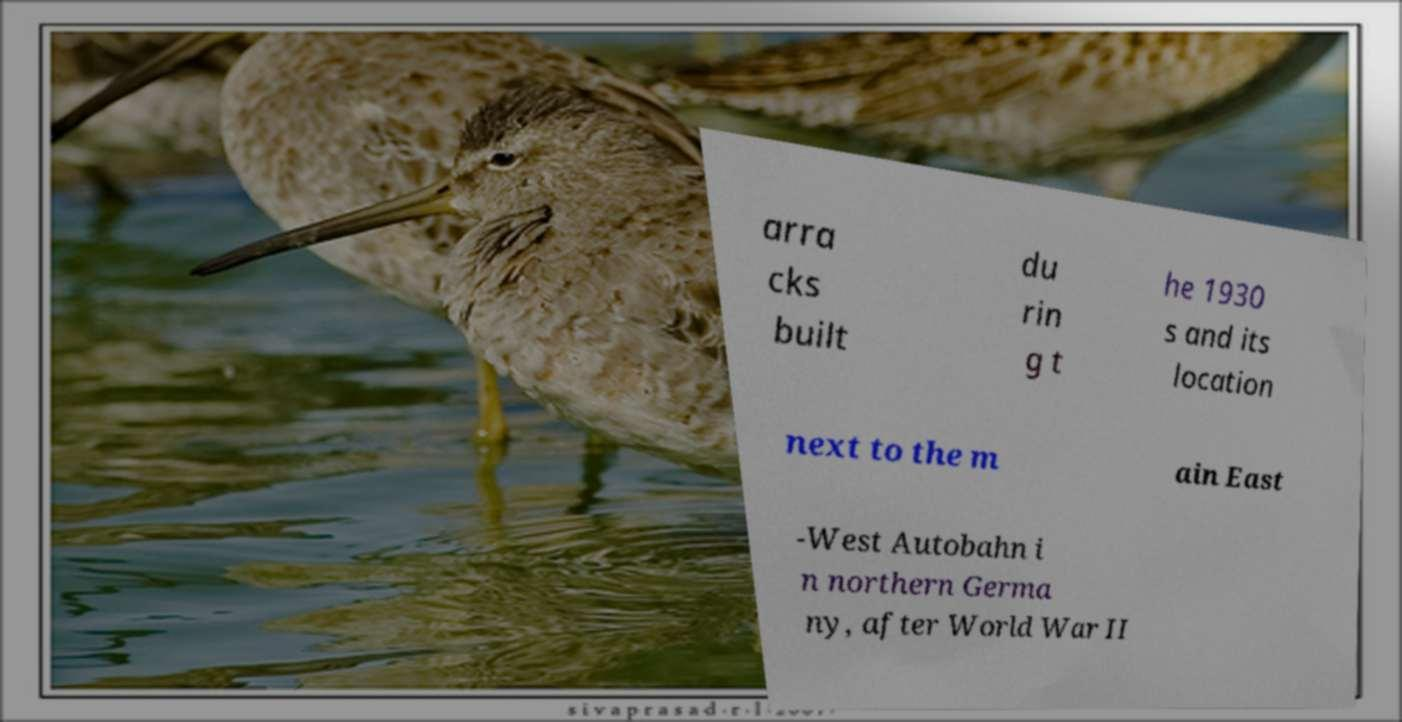Can you read and provide the text displayed in the image?This photo seems to have some interesting text. Can you extract and type it out for me? arra cks built du rin g t he 1930 s and its location next to the m ain East -West Autobahn i n northern Germa ny, after World War II 